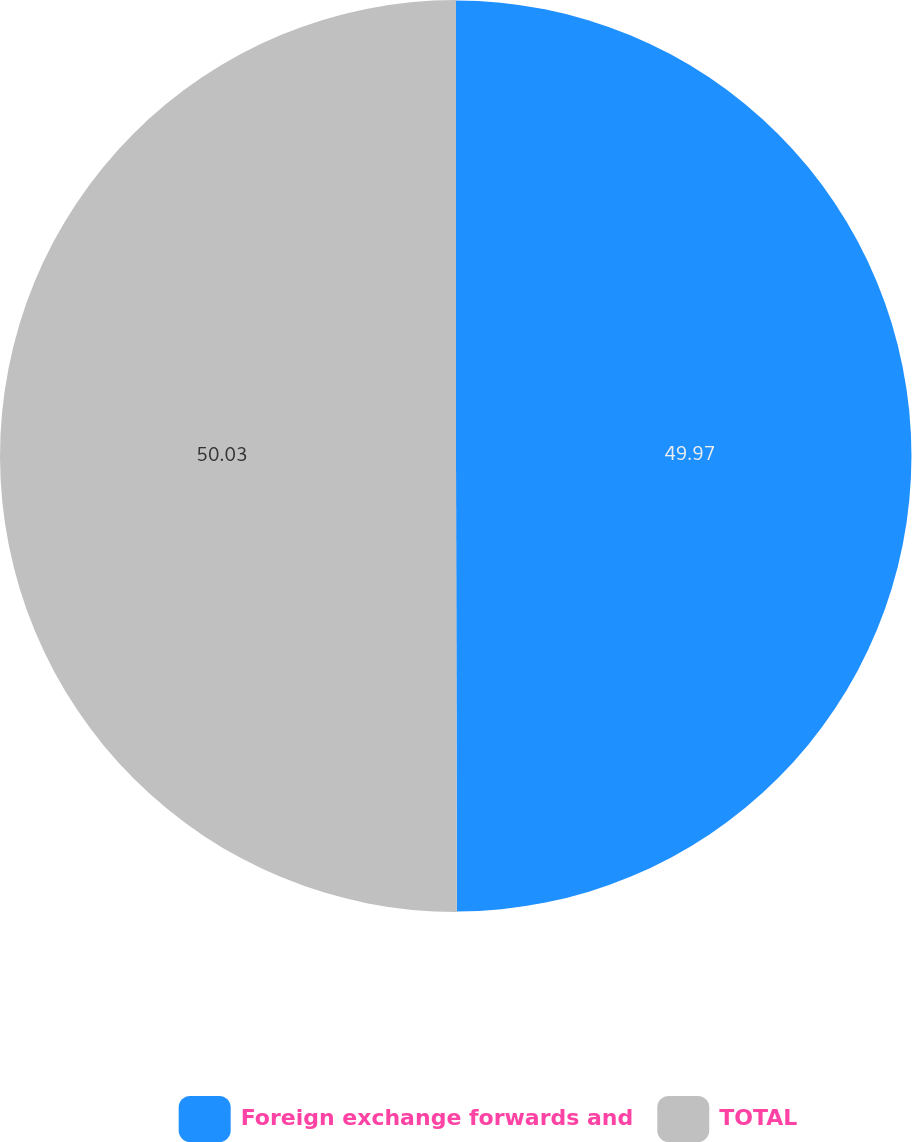<chart> <loc_0><loc_0><loc_500><loc_500><pie_chart><fcel>Foreign exchange forwards and<fcel>TOTAL<nl><fcel>49.97%<fcel>50.03%<nl></chart> 